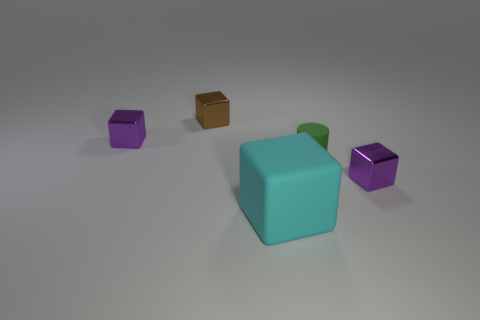Subtract all cyan cubes. How many cubes are left? 3 Subtract all blue blocks. Subtract all blue spheres. How many blocks are left? 4 Add 5 cyan cubes. How many objects exist? 10 Subtract all cylinders. How many objects are left? 4 Subtract 0 gray blocks. How many objects are left? 5 Subtract all tiny purple things. Subtract all small brown objects. How many objects are left? 2 Add 5 small shiny objects. How many small shiny objects are left? 8 Add 4 metallic objects. How many metallic objects exist? 7 